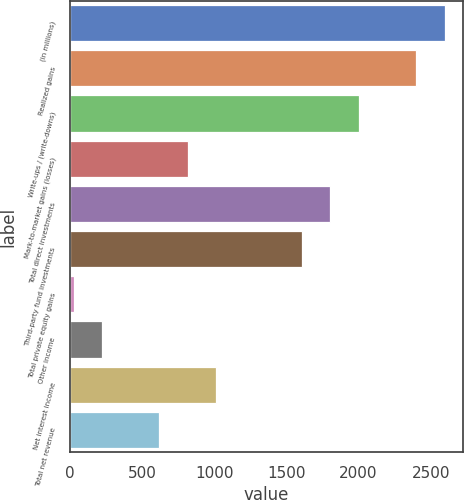<chart> <loc_0><loc_0><loc_500><loc_500><bar_chart><fcel>(in millions)<fcel>Realized gains<fcel>Write-ups / (write-downs)<fcel>Mark-to-market gains (losses)<fcel>Total direct investments<fcel>Third-party fund investments<fcel>Total private equity gains<fcel>Other income<fcel>Net interest income<fcel>Total net revenue<nl><fcel>2595.8<fcel>2398.2<fcel>2003<fcel>817.4<fcel>1805.4<fcel>1607.8<fcel>27<fcel>224.6<fcel>1015<fcel>619.8<nl></chart> 